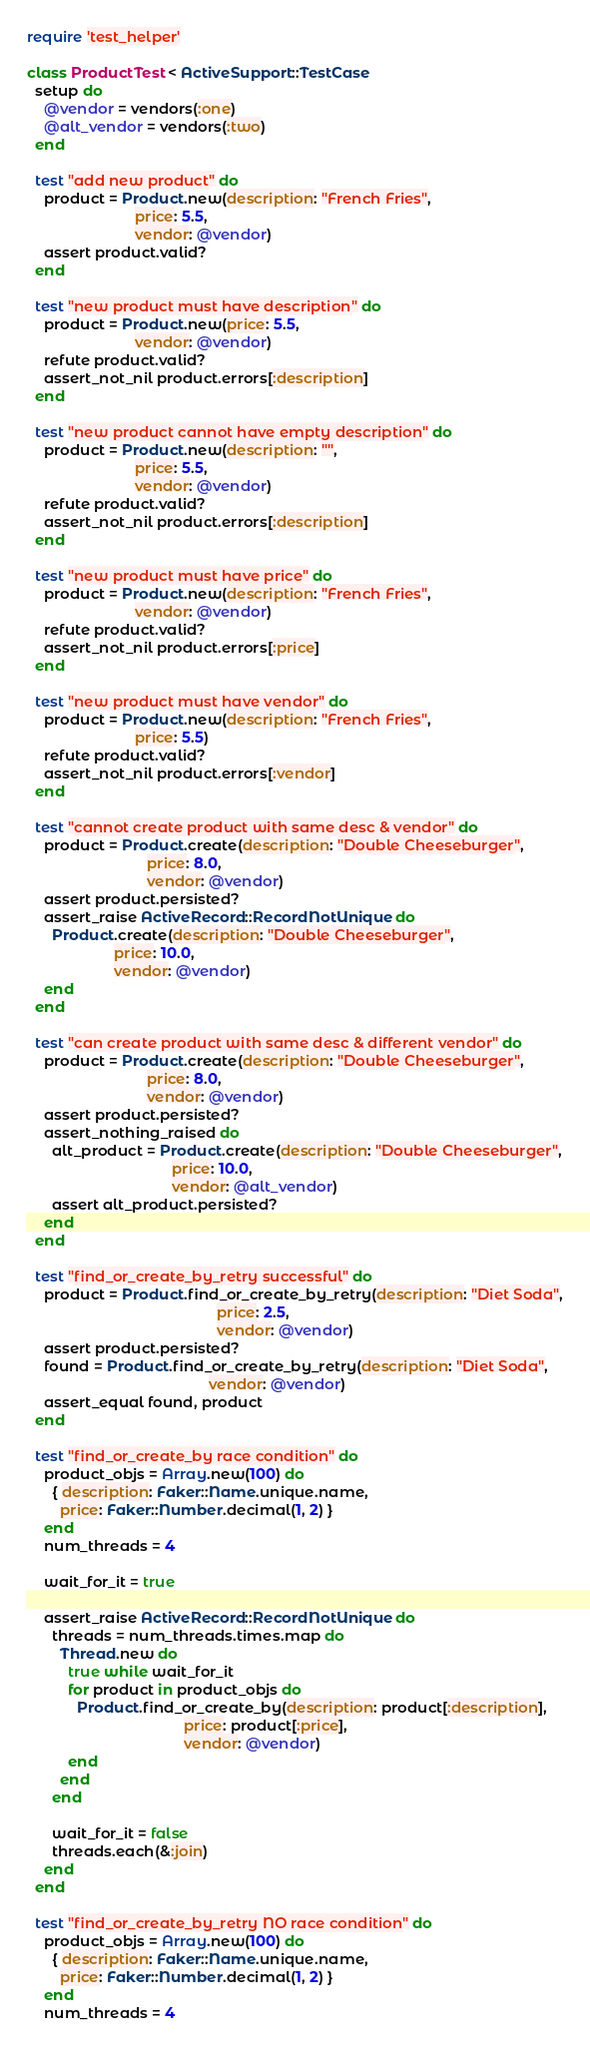Convert code to text. <code><loc_0><loc_0><loc_500><loc_500><_Ruby_>require 'test_helper'

class ProductTest < ActiveSupport::TestCase
  setup do
    @vendor = vendors(:one)
    @alt_vendor = vendors(:two)
  end

  test "add new product" do
    product = Product.new(description: "French Fries",
                          price: 5.5,
                          vendor: @vendor)
    assert product.valid?
  end

  test "new product must have description" do
    product = Product.new(price: 5.5,
                          vendor: @vendor)
    refute product.valid?
    assert_not_nil product.errors[:description]
  end

  test "new product cannot have empty description" do
    product = Product.new(description: "",
                          price: 5.5,
                          vendor: @vendor)
    refute product.valid?
    assert_not_nil product.errors[:description]
  end

  test "new product must have price" do
    product = Product.new(description: "French Fries",
                          vendor: @vendor)
    refute product.valid?
    assert_not_nil product.errors[:price]
  end

  test "new product must have vendor" do
    product = Product.new(description: "French Fries",
                          price: 5.5)
    refute product.valid?
    assert_not_nil product.errors[:vendor]
  end

  test "cannot create product with same desc & vendor" do
    product = Product.create(description: "Double Cheeseburger",
                             price: 8.0,
                             vendor: @vendor)
    assert product.persisted?
    assert_raise ActiveRecord::RecordNotUnique do
      Product.create(description: "Double Cheeseburger",
                     price: 10.0,
                     vendor: @vendor)
    end
  end

  test "can create product with same desc & different vendor" do
    product = Product.create(description: "Double Cheeseburger",
                             price: 8.0,
                             vendor: @vendor)
    assert product.persisted?
    assert_nothing_raised do
      alt_product = Product.create(description: "Double Cheeseburger",
                                   price: 10.0,
                                   vendor: @alt_vendor)
      assert alt_product.persisted?
    end
  end

  test "find_or_create_by_retry successful" do
    product = Product.find_or_create_by_retry(description: "Diet Soda",
                                              price: 2.5,
                                              vendor: @vendor)
    assert product.persisted?
    found = Product.find_or_create_by_retry(description: "Diet Soda",
                                            vendor: @vendor)
    assert_equal found, product
  end

  test "find_or_create_by race condition" do
    product_objs = Array.new(100) do
      { description: Faker::Name.unique.name,
        price: Faker::Number.decimal(1, 2) }
    end
    num_threads = 4

    wait_for_it = true

    assert_raise ActiveRecord::RecordNotUnique do
      threads = num_threads.times.map do
        Thread.new do
          true while wait_for_it
          for product in product_objs do
            Product.find_or_create_by(description: product[:description],
                                      price: product[:price],
                                      vendor: @vendor)
          end
        end
      end

      wait_for_it = false
      threads.each(&:join)
    end
  end

  test "find_or_create_by_retry NO race condition" do
    product_objs = Array.new(100) do
      { description: Faker::Name.unique.name,
        price: Faker::Number.decimal(1, 2) }
    end
    num_threads = 4
</code> 